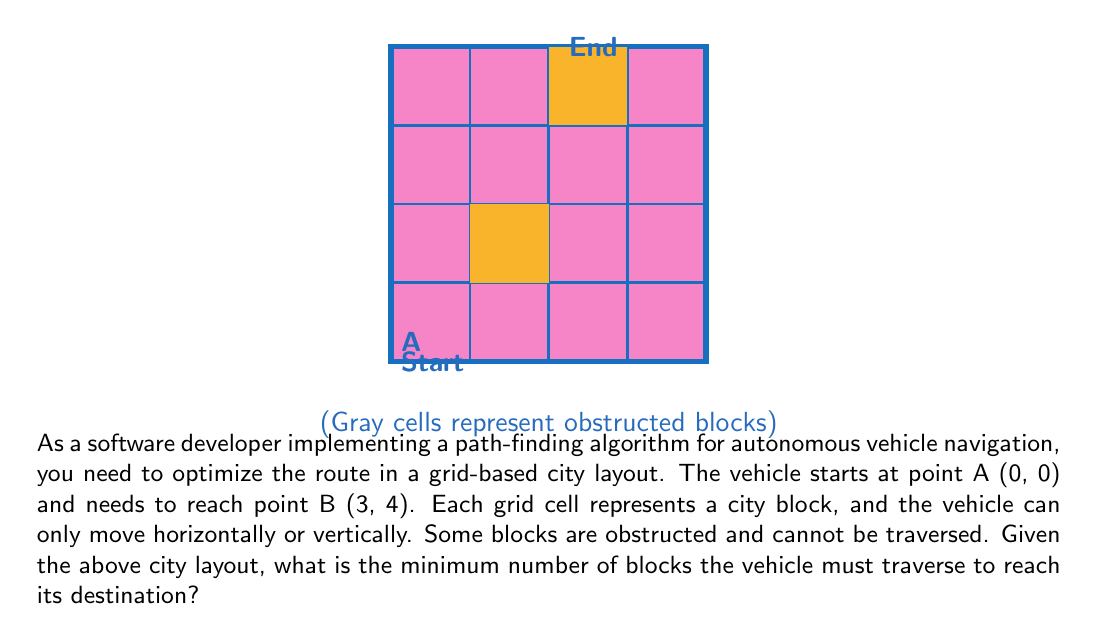Can you answer this question? To solve this problem, we can use a pathfinding algorithm such as A* or Dijkstra's algorithm. However, for simplicity, we'll use a step-by-step approach to find the shortest path:

1. Identify possible moves: The vehicle can move up, down, left, or right, but not diagonally.

2. Analyze the grid:
   - Start point: (0, 0)
   - End point: (3, 4)
   - Obstructions: (1, 1), (2, 1), (1, 2), (2, 2), (2, 3), (3, 3)

3. Find the shortest path:
   a. Move right: (0, 0) -> (1, 0)
   b. Move right: (1, 0) -> (2, 0)
   c. Move right: (2, 0) -> (3, 0)
   d. Move up: (3, 0) -> (3, 1)
   e. Move up: (3, 1) -> (3, 2)
   f. Move left: (3, 2) -> (2, 2)
   g. Move up: (2, 2) -> (2, 3)
   h. Move right: (2, 3) -> (3, 3)
   i. Move up: (3, 3) -> (3, 4)

4. Count the number of moves:
   The path consists of 9 moves from start to finish.

5. Verify optimality:
   This is the shortest possible path avoiding all obstacles. Any other route would require more moves or pass through obstructed blocks.

The minimum number of blocks the vehicle must traverse is therefore 9.
Answer: 9 blocks 